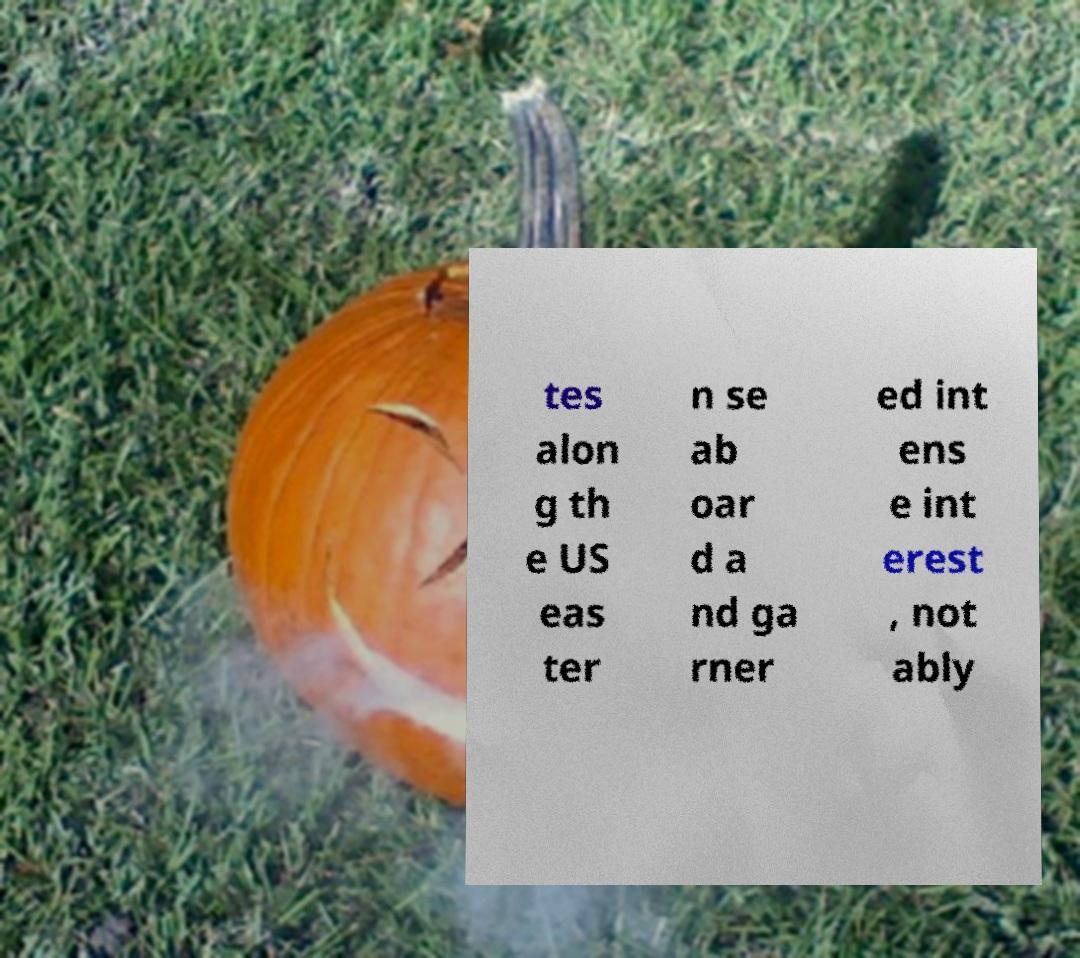For documentation purposes, I need the text within this image transcribed. Could you provide that? tes alon g th e US eas ter n se ab oar d a nd ga rner ed int ens e int erest , not ably 